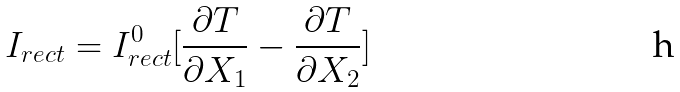Convert formula to latex. <formula><loc_0><loc_0><loc_500><loc_500>I _ { r e c t } = I _ { r e c t } ^ { 0 } [ \frac { \partial T } { \partial X _ { 1 } } - \frac { \partial T } { \partial X _ { 2 } } ]</formula> 